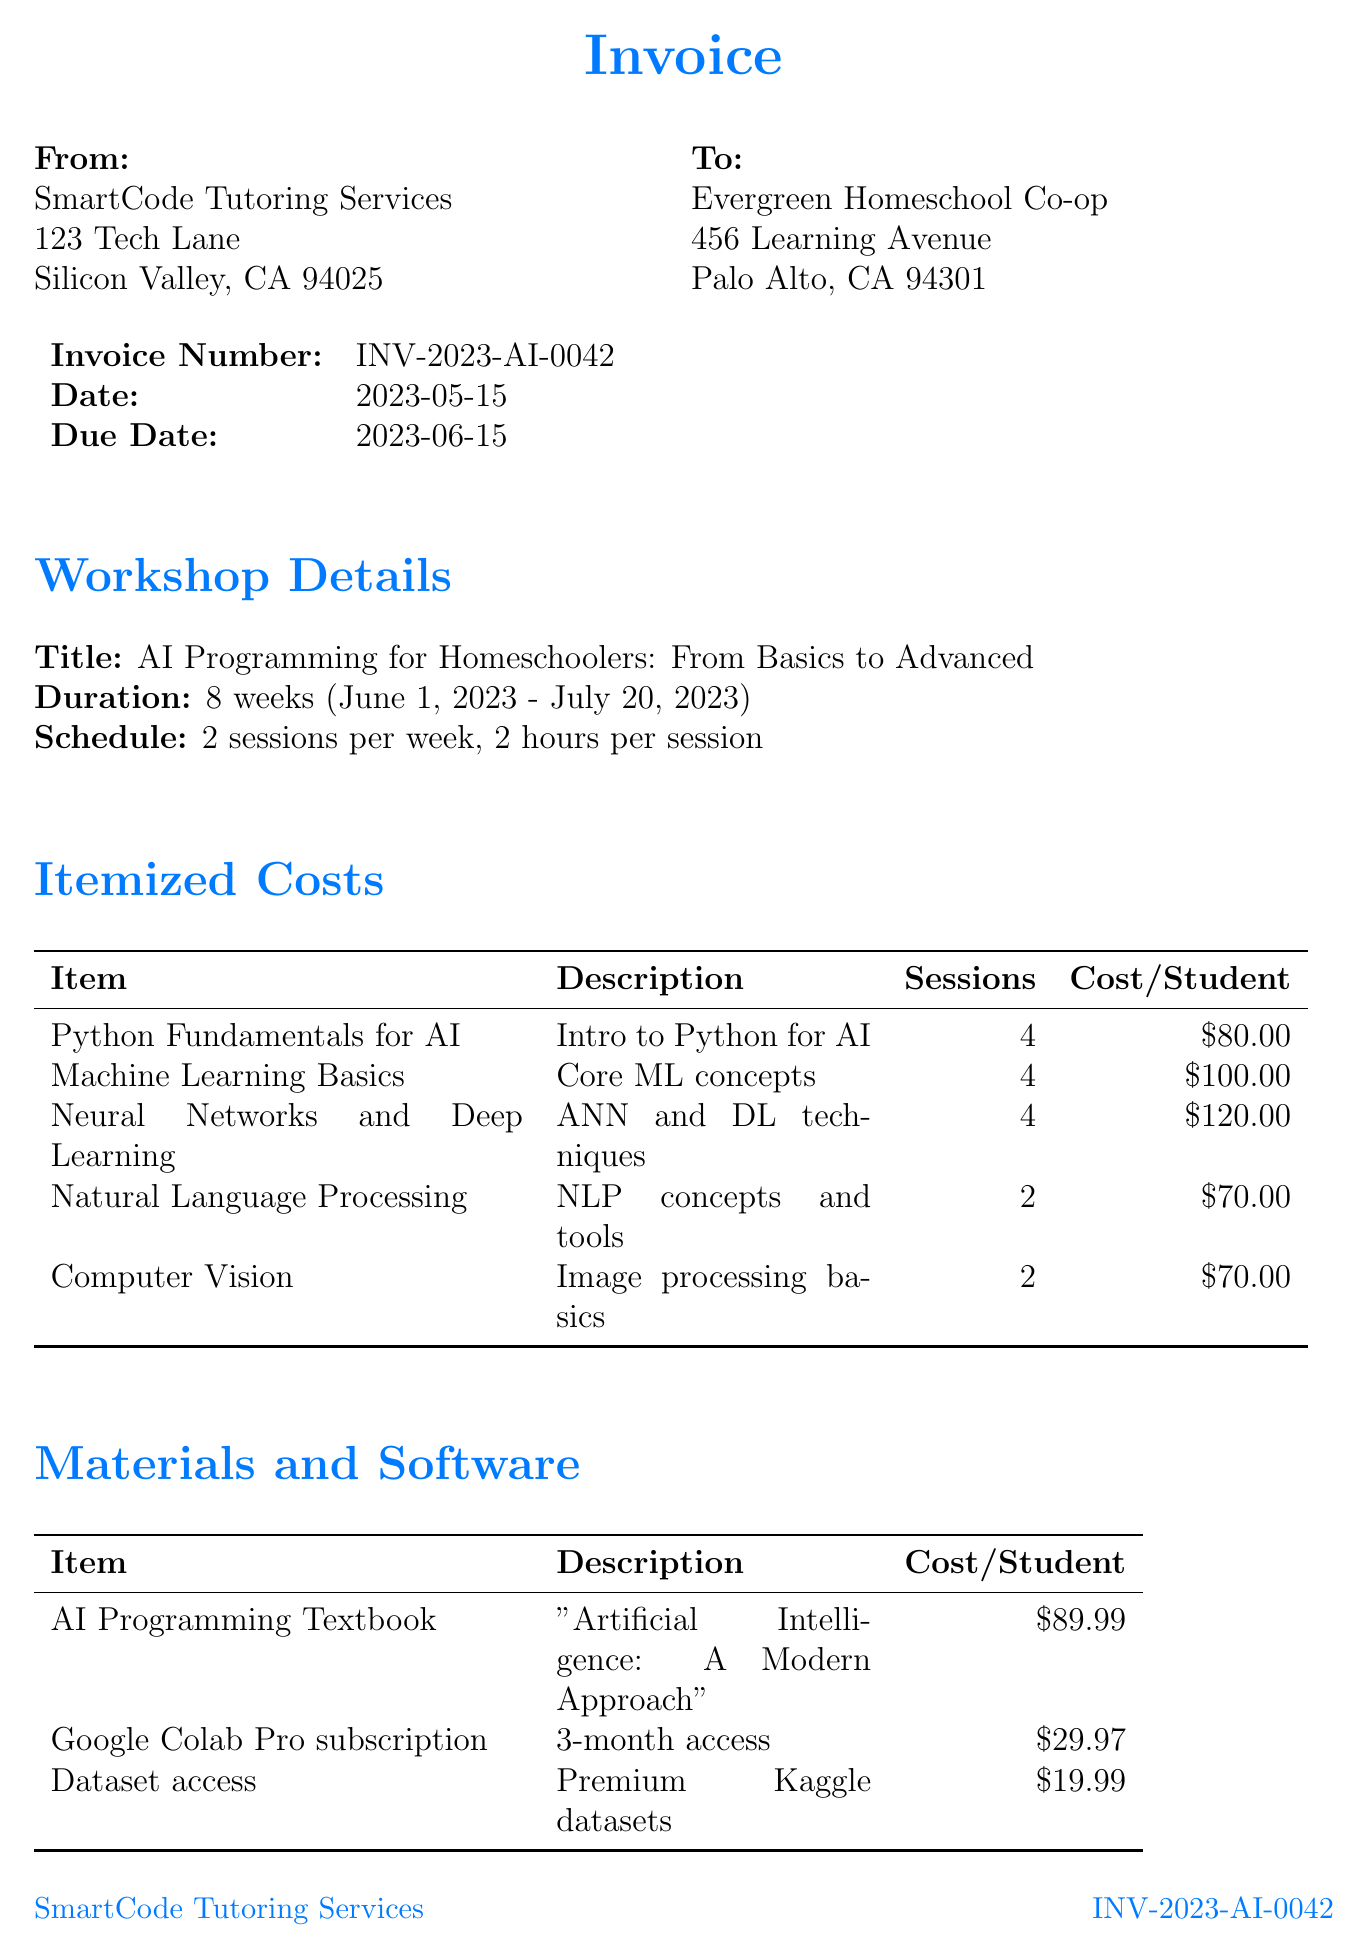What is the invoice number? The invoice number is stated in the document as a unique identifier for the invoice.
Answer: INV-2023-AI-0042 Who is the issuer of the invoice? The issuer's name is listed on the invoice along with their address.
Answer: SmartCode Tutoring Services What is the total cost per student for "Neural Networks and Deep Learning"? The cost per student for this workshop is specified in the itemized costs section of the invoice.
Answer: 120 How many sessions are included for "Machine Learning Basics"? The number of sessions is detailed in the itemized list for the workshop.
Answer: 4 What is the discount percentage for 10 to 14 students? The discount percentages are listed in the group discounts section, providing different rates based on student numbers.
Answer: 10% What is the start date of the workshop series? The start date is mentioned in the workshop details section of the invoice.
Answer: 2023-06-01 How much is the one-on-one tutoring per session? The cost is indicated in the additional services section of the invoice.
Answer: 50 What is the due date for the payment? The due date is specified for the invoice to be settled by the stated time.
Answer: 2023-06-15 What is the title of the workshop series? The title is found in the workshop details section, summarizing the main focus of the series.
Answer: AI Programming for Homeschoolers: From Basics to Advanced 